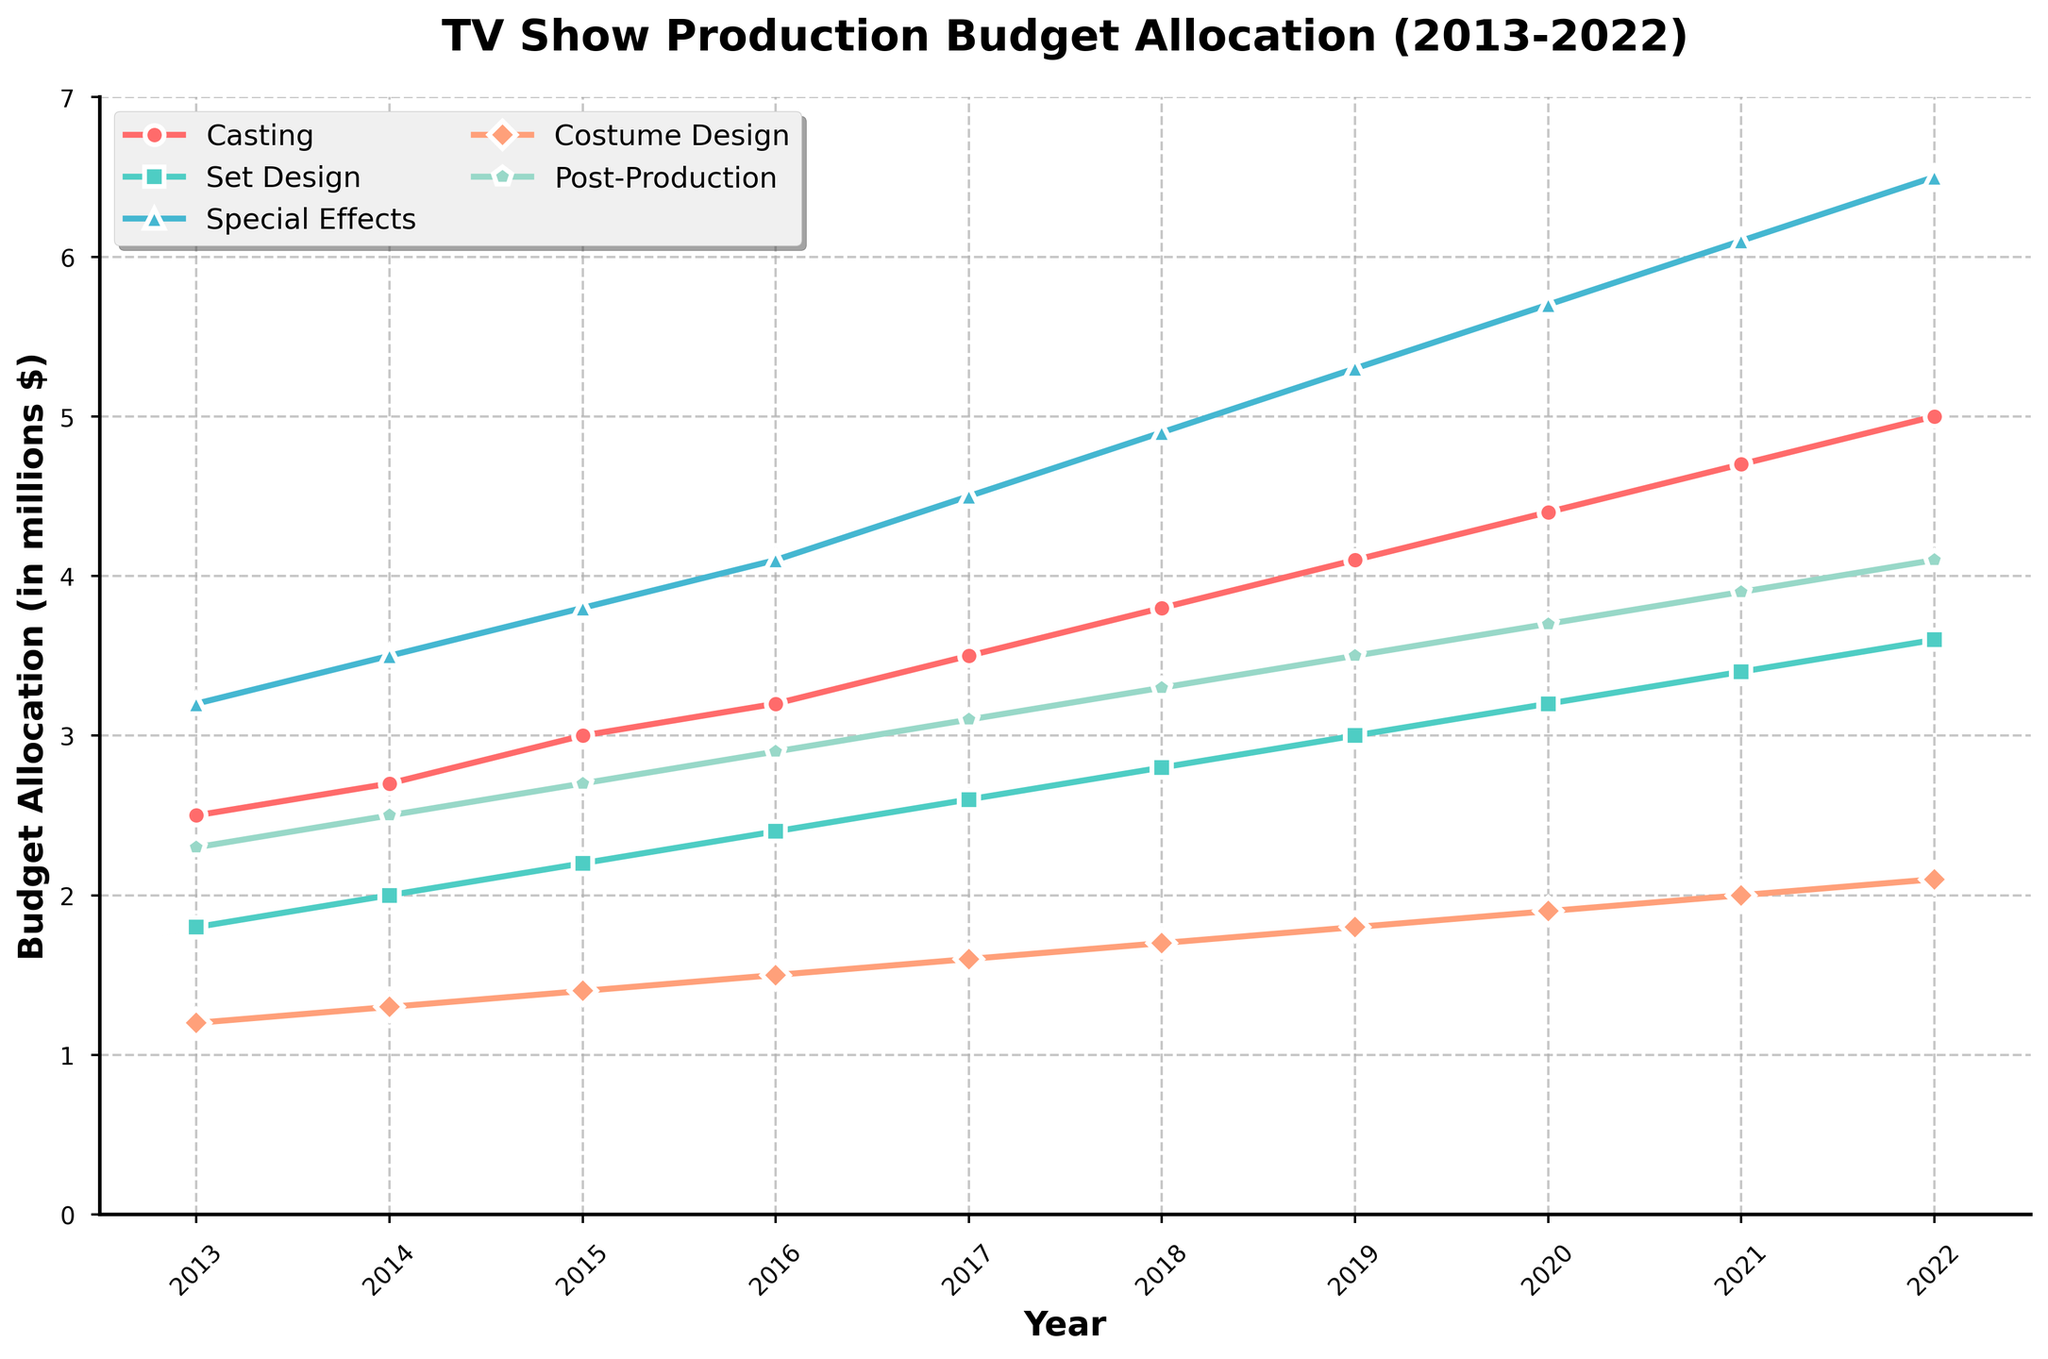What is the total budget allocation in 2018 for all production departments? First, find the budget for each department in 2018: Casting (3.8), Set Design (2.8), Special Effects (4.9), Costume Design (1.7), and Post-Production (3.3). Sum them up: 3.8 + 2.8 + 4.9 + 1.7 + 3.3 = 16.5
Answer: 16.5 Which department had the highest budget allocation in 2022? Locate the budget allocations for 2022: Casting (5.0), Set Design (3.6), Special Effects (6.5), Costume Design (2.1), and Post-Production (4.1). The highest value is for Special Effects at 6.5
Answer: Special Effects How did the budget for Casting change from 2013 to 2022? The budget for Casting in 2013 was 2.5 and in 2022 it was 5.0. The change is calculated by subtracting the 2013 value from the 2022 value: 5.0 - 2.5 = 2.5
Answer: Increased by 2.5 million What is the average annual budget allocation for Set Design from 2013 to 2022? Sum the annual budgets for Set Design over the years: 1.8 + 2.0 + 2.2 + 2.4 + 2.6 + 2.8 + 3.0 + 3.2 + 3.4 + 3.6 = 27. Calculating the average: 27 / 10 = 2.7
Answer: 2.7 million Compare the budget allocation for Special Effects and Post-Production in 2017. Which one had a higher share, and by how much? The budget for Special Effects in 2017 was 4.5, and for Post-Production, it was 3.1. Calculate the difference: 4.5 - 3.1 = 1.4. Special Effects had a higher share by 1.4 million
Answer: Special Effects by 1.4 million What was the trend in the budget allocation for Costume Design over the decade? Look at the budget allocation values for Costume Design from 2013 to 2022: 1.2, 1.3, 1.4, 1.5, 1.6, 1.7, 1.8, 1.9, 2.0, 2.1. The values show a consistent yearly increase
Answer: Consistently increasing Which year saw the largest increment in budget allocation for Set Design compared to its previous year? Calculate the yearly increments for Set Design: 2.0 - 1.8 = 0.2 (2014), 2.2 - 2.0 = 0.2 (2015), 2.4 - 2.2 = 0.2 (2016), 2.6 - 2.4 = 0.2 (2017), 2.8 - 2.6 = 0.2 (2018), 3.0 - 2.8 = 0.2 (2019), 3.2 - 3.0 = 0.2 (2020), 3.4 - 3.2 = 0.2 (2021), 3.6 - 3.4 = 0.2 (2022). All increments are equal
Answer: All increments are 0.2 By how much did the budget allocation for Post-Production grow from 2015 to 2022? The budget for Post-Production in 2015 was 2.7, and in 2022 it was 4.1. The growth is calculated by subtracting the 2015 value from the 2022 value: 4.1 - 2.7 = 1.4
Answer: 1.4 million In which year did Casting and Special Effects have the same growth rate from their previous year's budget allocation? Calculate the growth rate for each year by subtracting the values of the previous year: Casting (0.2 in 2014, 0.3 in 2015, 0.2 in 2016, 0.3 in 2017, 0.3 in 2018, 0.3 in 2019, 0.3 in 2020, 0.3 in 2021, 0.3 in 2022); Special Effects (0.3 in 2014, 0.3 in 2015, 0.3 in 2016, 0.4 in 2017, 0.4 in 2018, 0.4 in 2019, 0.4 in 2020, 0.4 in 2021, 0.4 in 2022). They both had the same growth rate of 0.3 from 2014 to 2015
Answer: 2015 